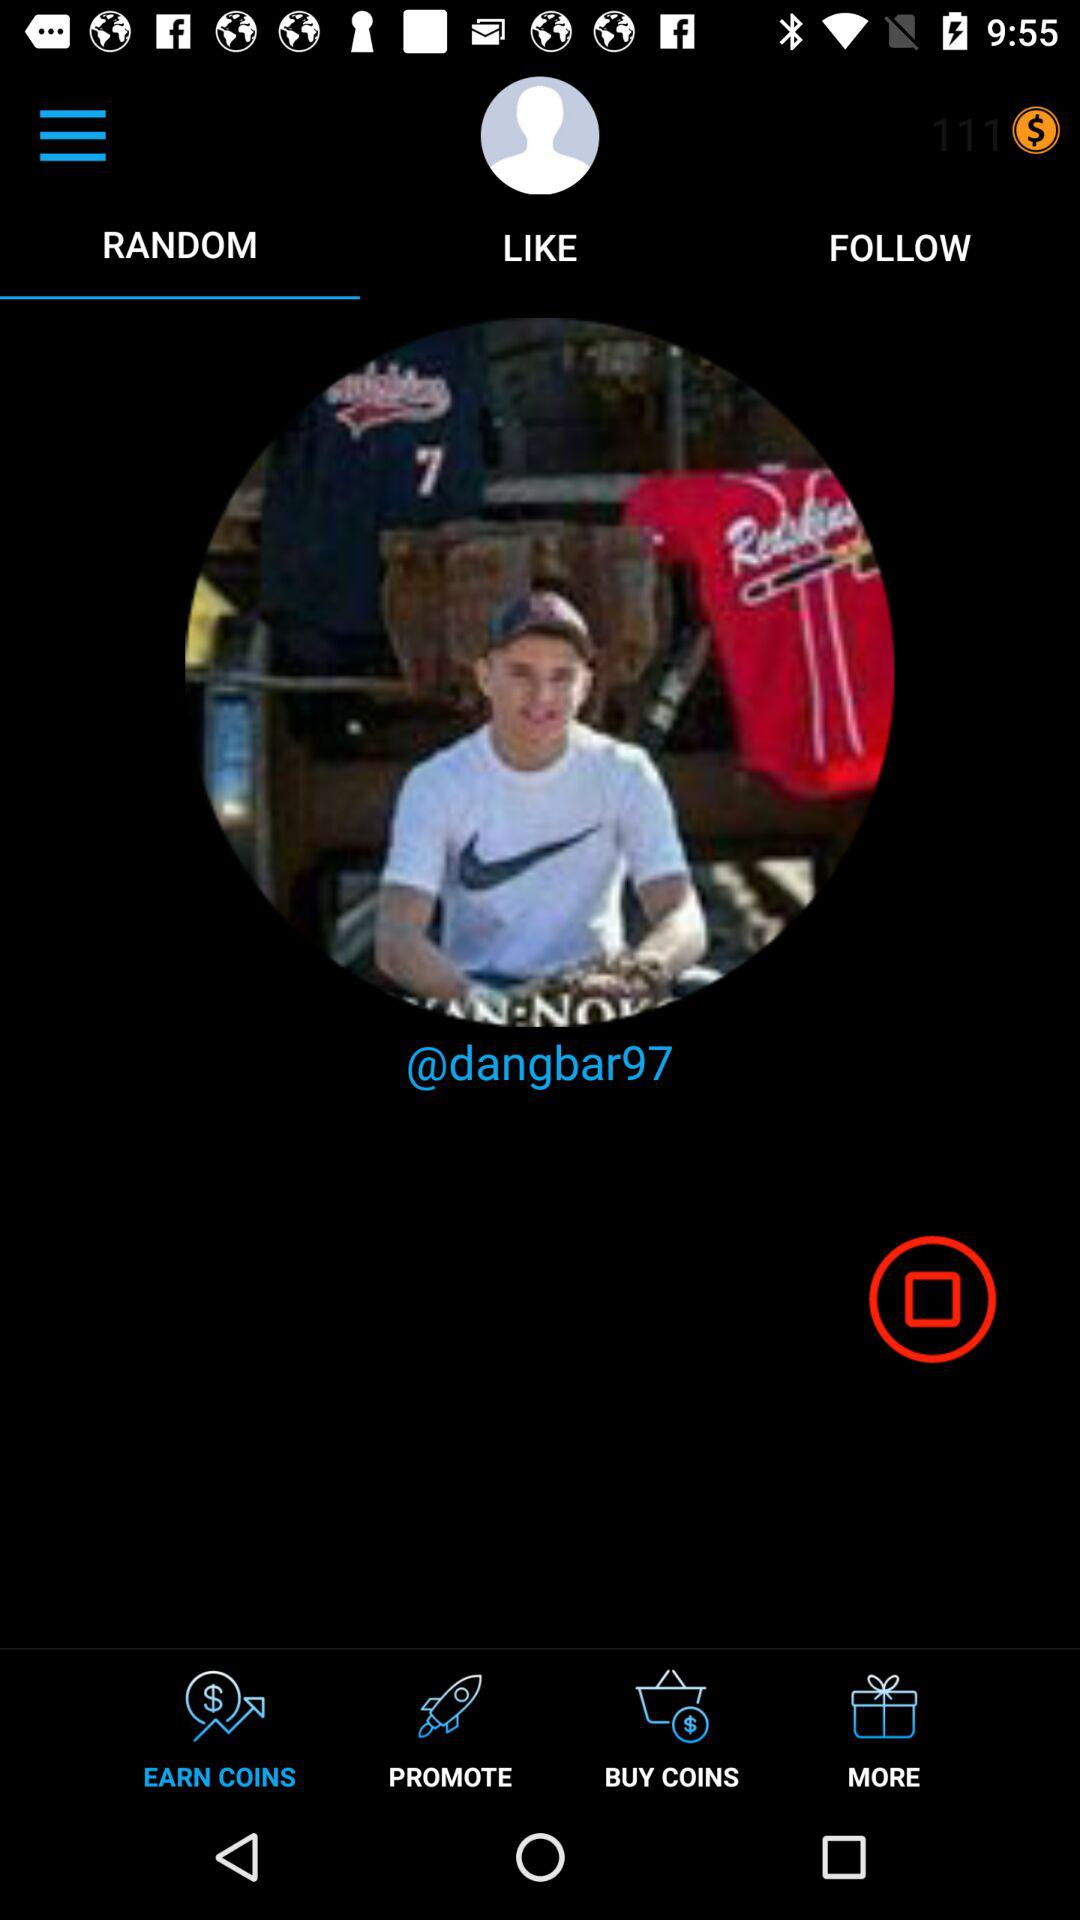Which tab is selected? The selected tab is "RANDOM". 